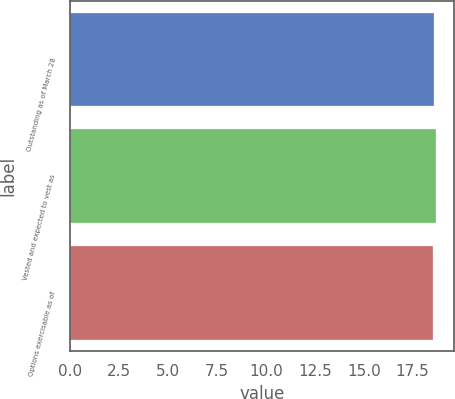Convert chart to OTSL. <chart><loc_0><loc_0><loc_500><loc_500><bar_chart><fcel>Outstanding as of March 28<fcel>Vested and expected to vest as<fcel>Options exercisable as of<nl><fcel>18.61<fcel>18.68<fcel>18.55<nl></chart> 